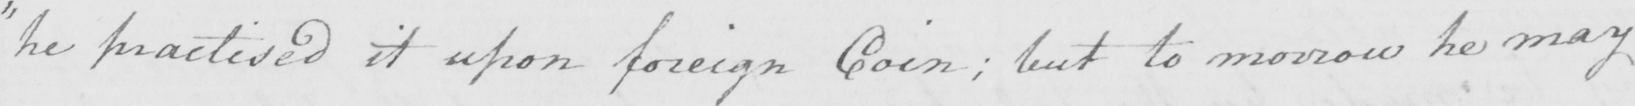Please transcribe the handwritten text in this image. " he practised it upon foreign Coin  ; but to morrow he may 